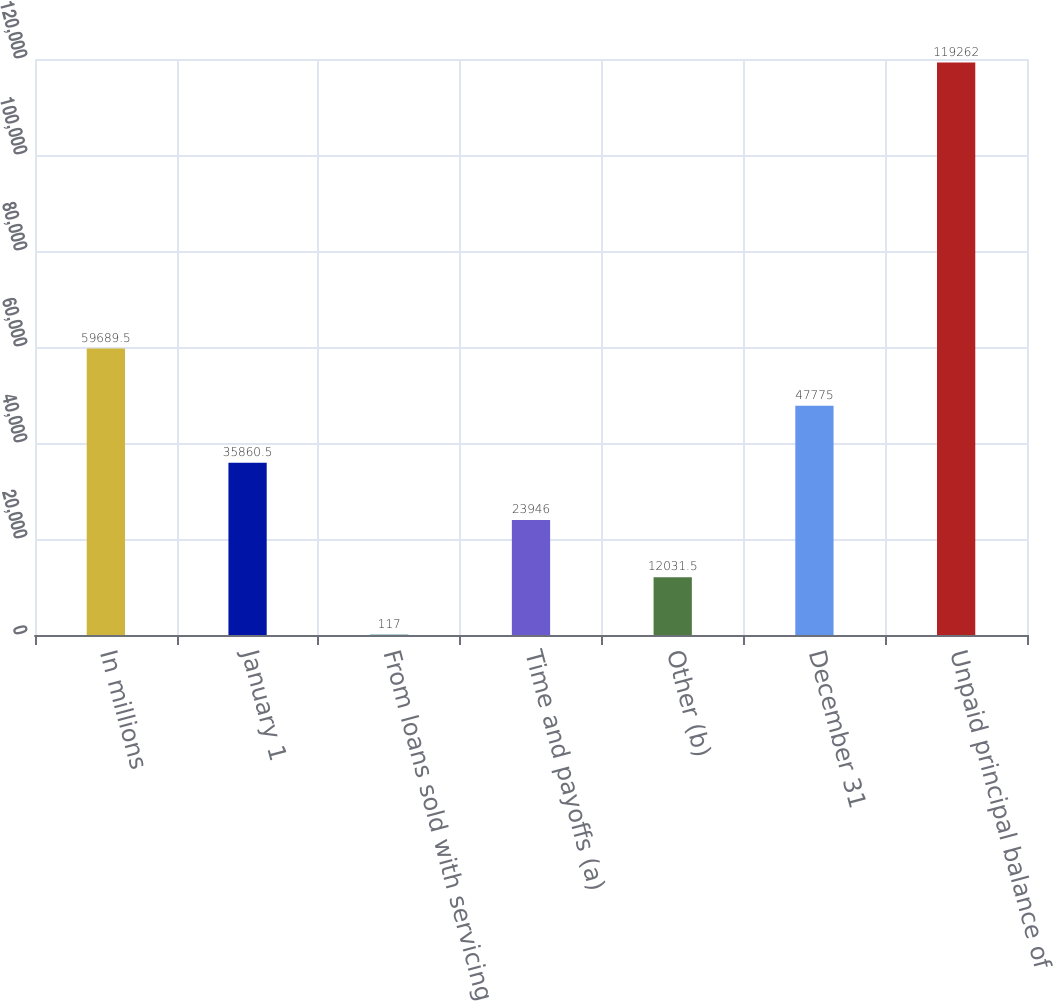<chart> <loc_0><loc_0><loc_500><loc_500><bar_chart><fcel>In millions<fcel>January 1<fcel>From loans sold with servicing<fcel>Time and payoffs (a)<fcel>Other (b)<fcel>December 31<fcel>Unpaid principal balance of<nl><fcel>59689.5<fcel>35860.5<fcel>117<fcel>23946<fcel>12031.5<fcel>47775<fcel>119262<nl></chart> 